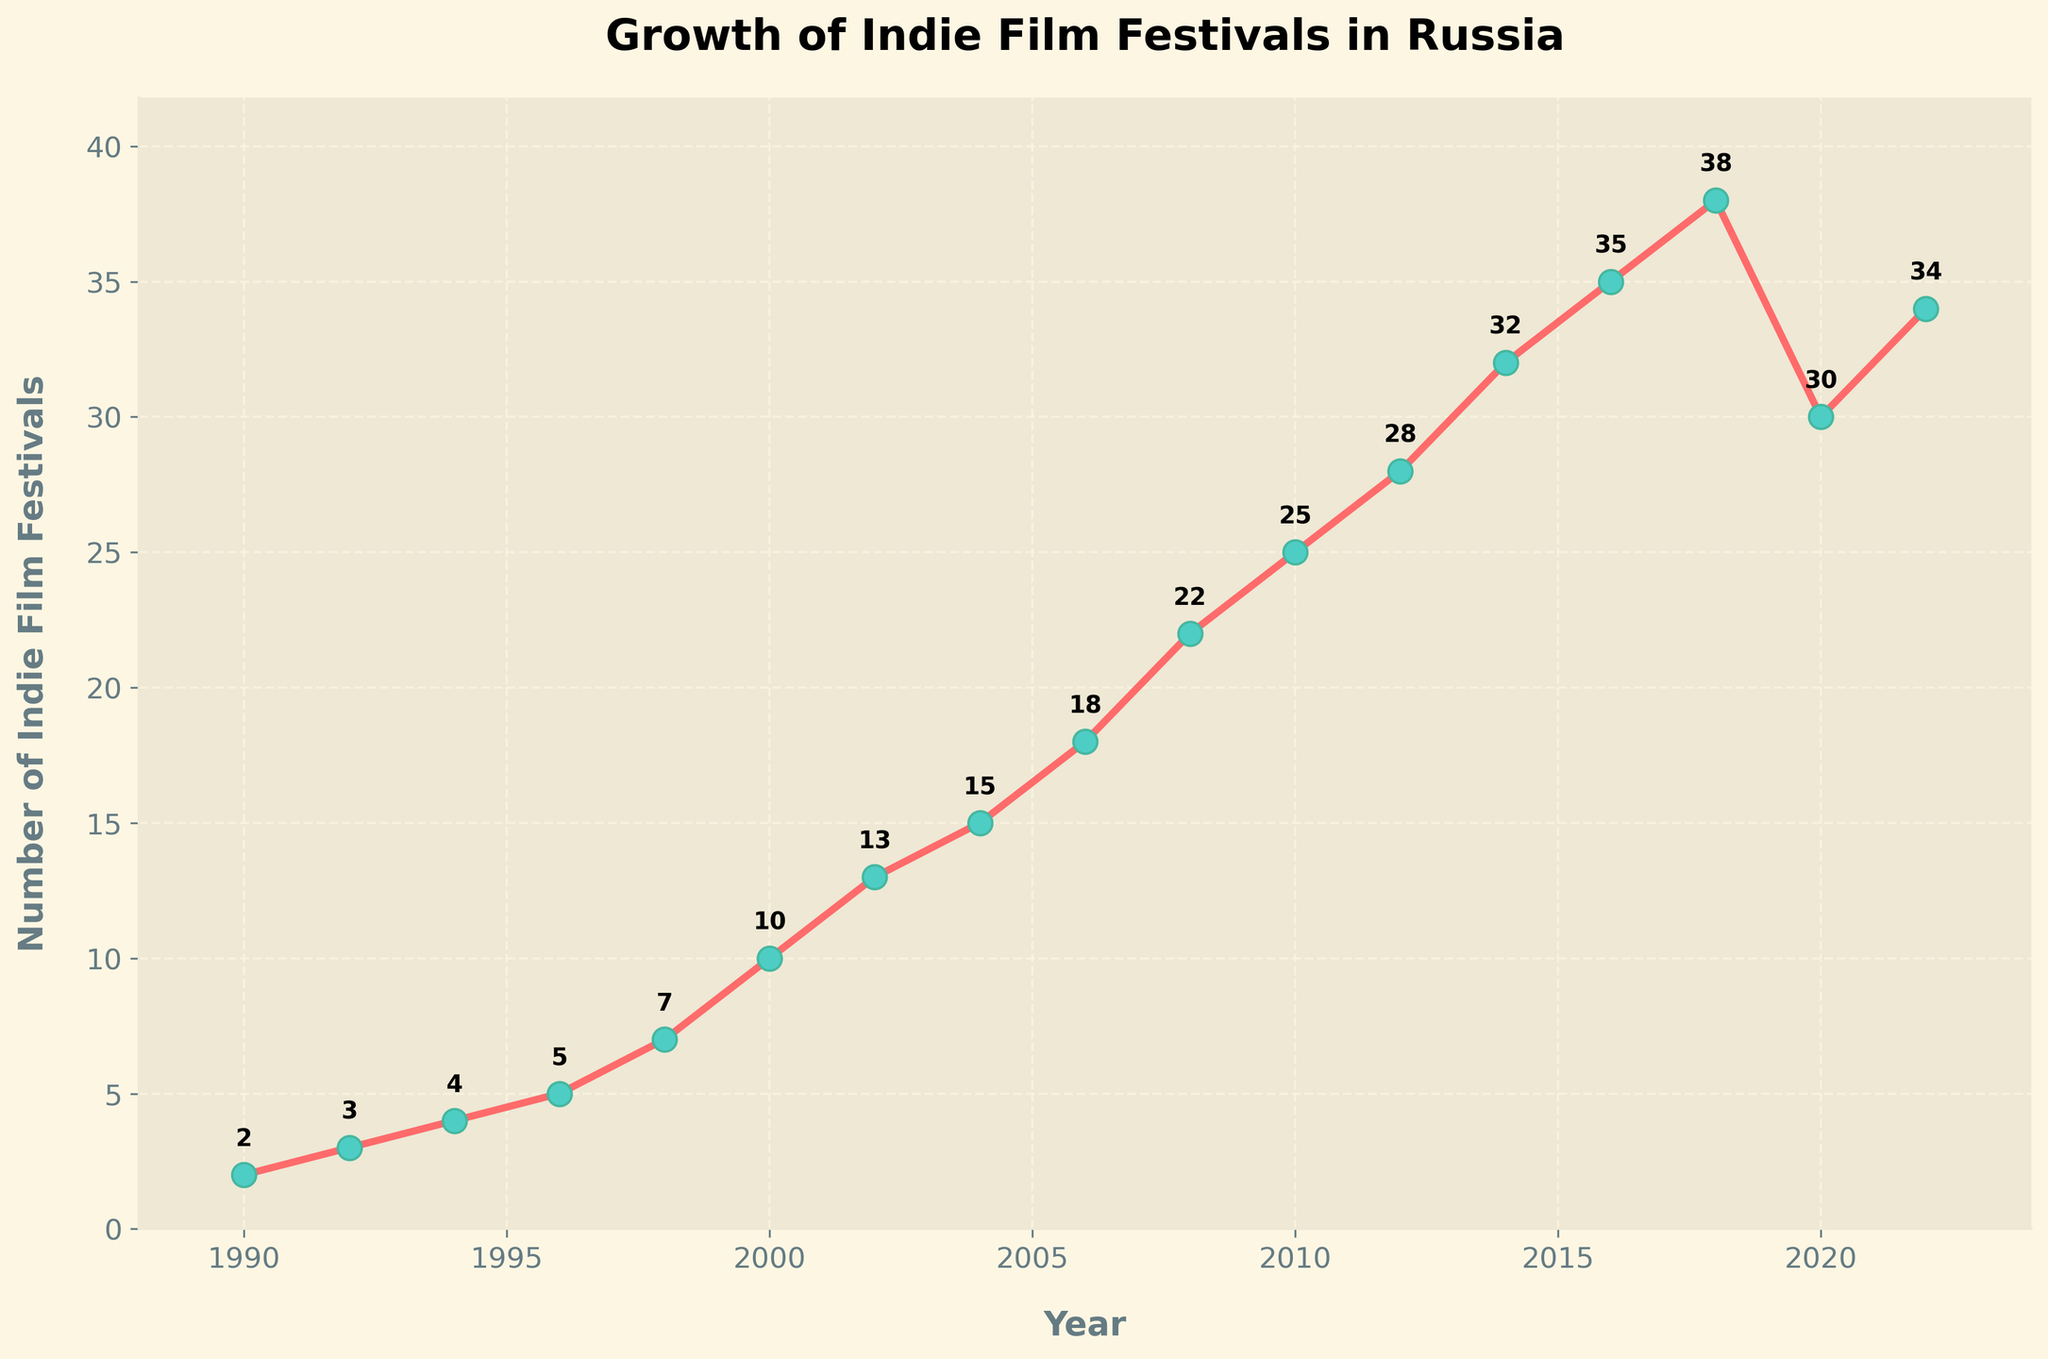How many indie film festivals were held in 2020 compared to 2022? To answer this, refer to the points corresponding to the years 2020 and 2022 on the chart. The number of festivals held in 2020 is 30, while in 2022 it is 34.
Answer: 2020: 30, 2022: 34 What is the average number of indie film festivals held between 2002 and 2006? First, identify the number of festivals for the years 2002 (13), 2004 (15), and 2006 (18). Add these numbers: 13 + 15 + 18 = 46. Then divide by the number of years: 46 / 3 = 15.33.
Answer: 15.33 In which year did the number of indie film festivals first exceed 20? Look at the chart and find the year where the data point for the number of festivals first exceeds 20. This happens in 2008 with 22 festivals.
Answer: 2008 Which year had the maximum number of indie film festivals? Find the highest point on the chart. The year with the maximum value is 2018, with 38 festivals.
Answer: 2018 Did the number of indie film festivals ever decrease from one year to the next? If so, in which period? Scan the chart and look for any drop between consecutive years. The number decreases from 2018 (38) to 2020 (30).
Answer: 2018-2020 What was the total increase in the number of festivals from 1990 to 2000? Find the values for 1990 (2) and 2000 (10). Subtract the 1990 value from the 2000 value: 10 - 2 = 8.
Answer: 8 How many indie film festivals were added in total from 1990 to 2022? Subtract the value for 1990 (2) from the value for 2022 (34): 34 - 2 = 32.
Answer: 32 What trend can you observe in the number of indie film festivals from 1990 to 2018? Observe the chart from 1990 to 2018: there is a steady increase in the number of festivals, with an overall upward trend.
Answer: Upward trend Which two consecutive years had the highest increase in the number of festivals? Compare the differences between consecutive years: 2006-2008 shows an increase from 18 to 22, which is a rise of 4, the highest among all periods.
Answer: 2006-2008 Was there a year when the number of festivals was exactly 10? Check the chart for the number 10. In the year 2000, the number of festivals was exactly 10.
Answer: 2000 